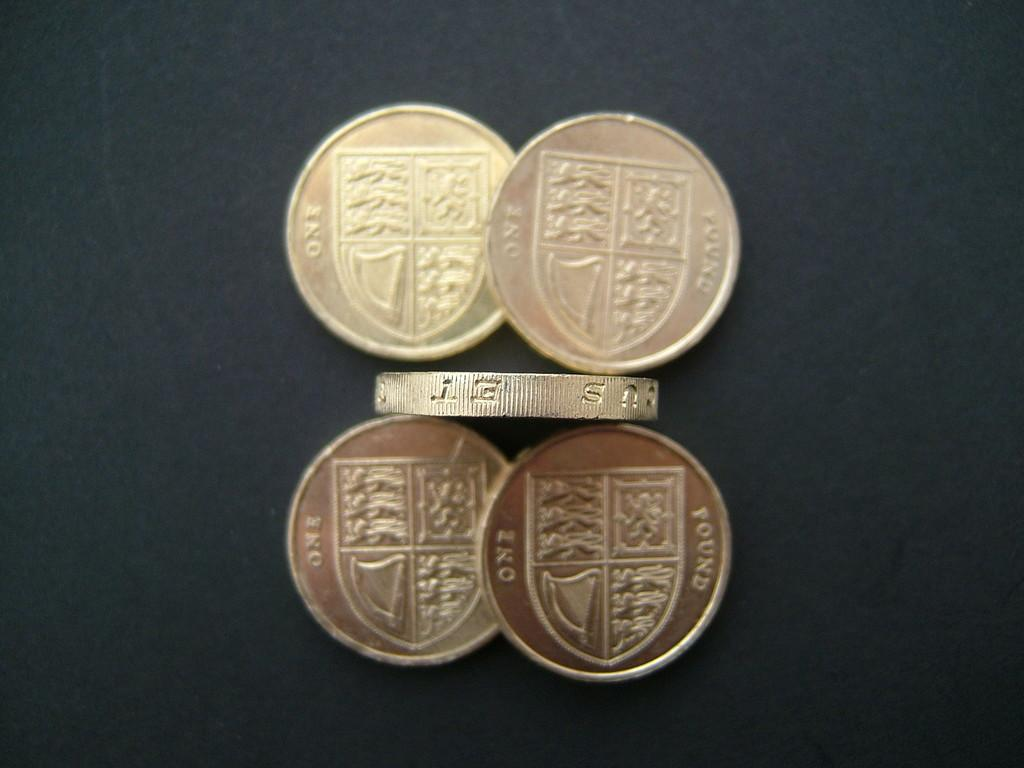<image>
Describe the image concisely. Four coins engraved with one found on the back of them 